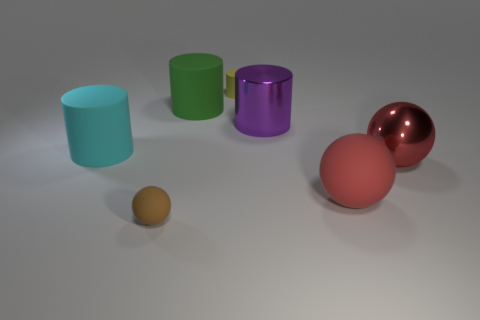Add 2 big rubber balls. How many objects exist? 9 Subtract all spheres. How many objects are left? 4 Subtract all cyan rubber cylinders. Subtract all green matte cylinders. How many objects are left? 5 Add 5 metal cylinders. How many metal cylinders are left? 6 Add 3 small brown rubber things. How many small brown rubber things exist? 4 Subtract 0 yellow cubes. How many objects are left? 7 